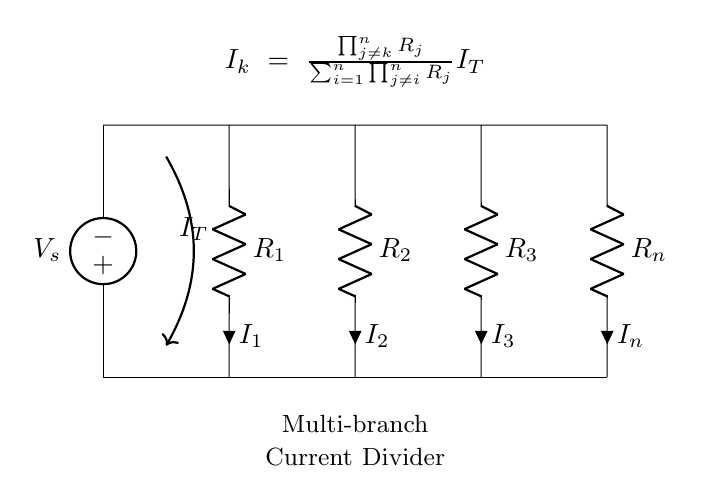What is the source voltage in this circuit? The source voltage, denoted as V_s, is the vertical voltage source at the top of the circuit. It supplies voltage to the parallel resistors connected below it.
Answer: V_s How many resistors are there in the circuit? The circuit diagram shows a total of four resistors represented by R_1, R_2, R_3, and R_n. Each of these is connected in parallel to the voltage source.
Answer: 4 What is the total current flowing into the network? The total current, represented by I_T, is shown by the arrow labeled I_T entering the circuit. This current splits between the branches formed by the resistors.
Answer: I_T Which resistor has current denoted as I_2? The resistor labeled R_2 is associated with the current denoted as I_2, indicated by the current arrow next to it in the circuit diagram.
Answer: R_2 What is the formula for the current through resistor k? The formula provided in the diagram describes how the current I_k through resistor k is determined based on the resistances of other resistors and the total current. The formula is I_k = (product of other resistances) / (sum of products of other resistances) * I_T. This represents the current division principle applied here.
Answer: I_k = \frac{\prod_{j\neq k}^n R_j}{\sum_{i=1}^n \prod_{j\neq i}^n R_j} I_T How does increasing resistance R_3 affect I_3? Increasing resistance R_3 decreases the current I_3 flowing through that branch because more resistance leads to less current according to Ohm's law and the rules of a current divider circuit. The current will also redistribute among the other branches.
Answer: Decrease I_3 